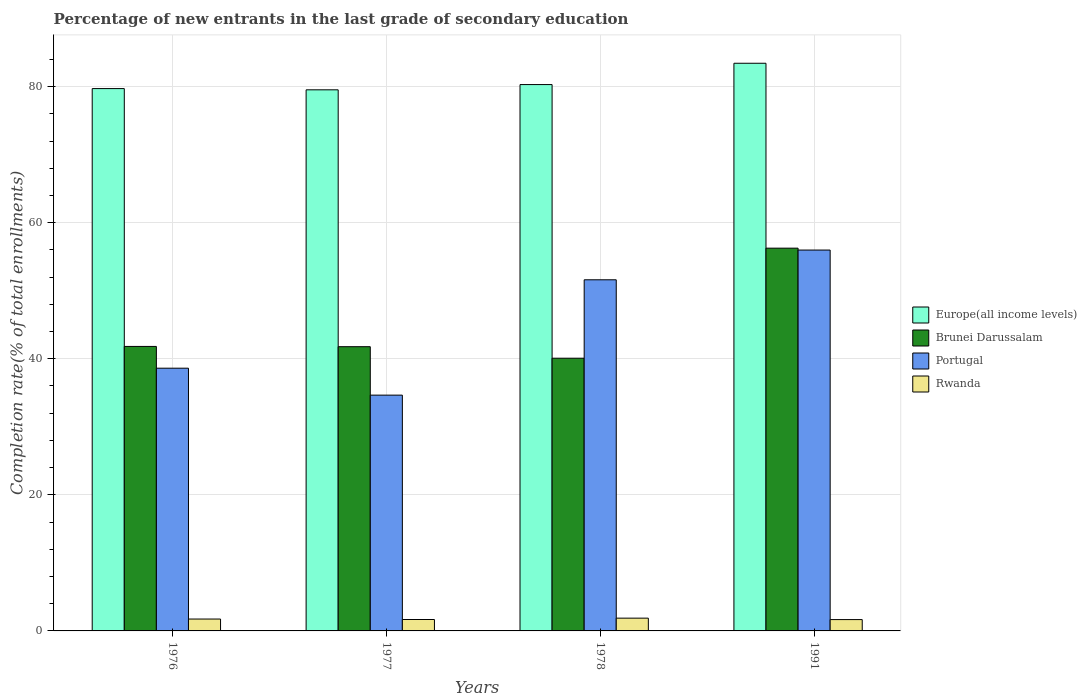How many groups of bars are there?
Make the answer very short. 4. How many bars are there on the 4th tick from the left?
Your answer should be compact. 4. How many bars are there on the 4th tick from the right?
Provide a succinct answer. 4. What is the label of the 4th group of bars from the left?
Ensure brevity in your answer.  1991. What is the percentage of new entrants in Brunei Darussalam in 1978?
Provide a short and direct response. 40.08. Across all years, what is the maximum percentage of new entrants in Europe(all income levels)?
Ensure brevity in your answer.  83.43. Across all years, what is the minimum percentage of new entrants in Brunei Darussalam?
Provide a short and direct response. 40.08. In which year was the percentage of new entrants in Portugal maximum?
Offer a very short reply. 1991. What is the total percentage of new entrants in Brunei Darussalam in the graph?
Your answer should be very brief. 179.92. What is the difference between the percentage of new entrants in Europe(all income levels) in 1977 and that in 1991?
Make the answer very short. -3.9. What is the difference between the percentage of new entrants in Rwanda in 1976 and the percentage of new entrants in Portugal in 1991?
Your response must be concise. -54.23. What is the average percentage of new entrants in Portugal per year?
Give a very brief answer. 45.21. In the year 1991, what is the difference between the percentage of new entrants in Portugal and percentage of new entrants in Brunei Darussalam?
Provide a short and direct response. -0.28. What is the ratio of the percentage of new entrants in Europe(all income levels) in 1976 to that in 1978?
Ensure brevity in your answer.  0.99. Is the difference between the percentage of new entrants in Portugal in 1976 and 1978 greater than the difference between the percentage of new entrants in Brunei Darussalam in 1976 and 1978?
Ensure brevity in your answer.  No. What is the difference between the highest and the second highest percentage of new entrants in Portugal?
Give a very brief answer. 4.37. What is the difference between the highest and the lowest percentage of new entrants in Brunei Darussalam?
Make the answer very short. 16.17. What does the 2nd bar from the right in 1977 represents?
Give a very brief answer. Portugal. Is it the case that in every year, the sum of the percentage of new entrants in Brunei Darussalam and percentage of new entrants in Europe(all income levels) is greater than the percentage of new entrants in Rwanda?
Provide a succinct answer. Yes. How many years are there in the graph?
Provide a short and direct response. 4. Are the values on the major ticks of Y-axis written in scientific E-notation?
Provide a succinct answer. No. Does the graph contain any zero values?
Offer a terse response. No. Does the graph contain grids?
Make the answer very short. Yes. How are the legend labels stacked?
Your response must be concise. Vertical. What is the title of the graph?
Offer a very short reply. Percentage of new entrants in the last grade of secondary education. What is the label or title of the X-axis?
Your answer should be very brief. Years. What is the label or title of the Y-axis?
Keep it short and to the point. Completion rate(% of total enrollments). What is the Completion rate(% of total enrollments) of Europe(all income levels) in 1976?
Provide a short and direct response. 79.71. What is the Completion rate(% of total enrollments) of Brunei Darussalam in 1976?
Provide a succinct answer. 41.81. What is the Completion rate(% of total enrollments) of Portugal in 1976?
Make the answer very short. 38.61. What is the Completion rate(% of total enrollments) of Rwanda in 1976?
Offer a very short reply. 1.75. What is the Completion rate(% of total enrollments) in Europe(all income levels) in 1977?
Ensure brevity in your answer.  79.53. What is the Completion rate(% of total enrollments) in Brunei Darussalam in 1977?
Offer a terse response. 41.77. What is the Completion rate(% of total enrollments) of Portugal in 1977?
Provide a short and direct response. 34.66. What is the Completion rate(% of total enrollments) of Rwanda in 1977?
Provide a short and direct response. 1.68. What is the Completion rate(% of total enrollments) in Europe(all income levels) in 1978?
Provide a succinct answer. 80.3. What is the Completion rate(% of total enrollments) in Brunei Darussalam in 1978?
Give a very brief answer. 40.08. What is the Completion rate(% of total enrollments) in Portugal in 1978?
Your response must be concise. 51.61. What is the Completion rate(% of total enrollments) of Rwanda in 1978?
Provide a succinct answer. 1.88. What is the Completion rate(% of total enrollments) in Europe(all income levels) in 1991?
Offer a very short reply. 83.43. What is the Completion rate(% of total enrollments) in Brunei Darussalam in 1991?
Keep it short and to the point. 56.26. What is the Completion rate(% of total enrollments) in Portugal in 1991?
Keep it short and to the point. 55.98. What is the Completion rate(% of total enrollments) of Rwanda in 1991?
Provide a short and direct response. 1.67. Across all years, what is the maximum Completion rate(% of total enrollments) in Europe(all income levels)?
Offer a terse response. 83.43. Across all years, what is the maximum Completion rate(% of total enrollments) of Brunei Darussalam?
Offer a very short reply. 56.26. Across all years, what is the maximum Completion rate(% of total enrollments) in Portugal?
Offer a terse response. 55.98. Across all years, what is the maximum Completion rate(% of total enrollments) of Rwanda?
Provide a succinct answer. 1.88. Across all years, what is the minimum Completion rate(% of total enrollments) of Europe(all income levels)?
Offer a very short reply. 79.53. Across all years, what is the minimum Completion rate(% of total enrollments) of Brunei Darussalam?
Ensure brevity in your answer.  40.08. Across all years, what is the minimum Completion rate(% of total enrollments) of Portugal?
Offer a terse response. 34.66. Across all years, what is the minimum Completion rate(% of total enrollments) in Rwanda?
Your answer should be compact. 1.67. What is the total Completion rate(% of total enrollments) of Europe(all income levels) in the graph?
Give a very brief answer. 322.97. What is the total Completion rate(% of total enrollments) in Brunei Darussalam in the graph?
Your answer should be compact. 179.92. What is the total Completion rate(% of total enrollments) in Portugal in the graph?
Ensure brevity in your answer.  180.86. What is the total Completion rate(% of total enrollments) of Rwanda in the graph?
Provide a succinct answer. 6.97. What is the difference between the Completion rate(% of total enrollments) of Europe(all income levels) in 1976 and that in 1977?
Your response must be concise. 0.18. What is the difference between the Completion rate(% of total enrollments) in Brunei Darussalam in 1976 and that in 1977?
Make the answer very short. 0.04. What is the difference between the Completion rate(% of total enrollments) in Portugal in 1976 and that in 1977?
Your answer should be compact. 3.96. What is the difference between the Completion rate(% of total enrollments) in Rwanda in 1976 and that in 1977?
Keep it short and to the point. 0.07. What is the difference between the Completion rate(% of total enrollments) of Europe(all income levels) in 1976 and that in 1978?
Your answer should be very brief. -0.59. What is the difference between the Completion rate(% of total enrollments) of Brunei Darussalam in 1976 and that in 1978?
Your answer should be compact. 1.73. What is the difference between the Completion rate(% of total enrollments) in Portugal in 1976 and that in 1978?
Your response must be concise. -12.99. What is the difference between the Completion rate(% of total enrollments) of Rwanda in 1976 and that in 1978?
Keep it short and to the point. -0.13. What is the difference between the Completion rate(% of total enrollments) in Europe(all income levels) in 1976 and that in 1991?
Offer a very short reply. -3.72. What is the difference between the Completion rate(% of total enrollments) in Brunei Darussalam in 1976 and that in 1991?
Give a very brief answer. -14.44. What is the difference between the Completion rate(% of total enrollments) of Portugal in 1976 and that in 1991?
Keep it short and to the point. -17.36. What is the difference between the Completion rate(% of total enrollments) of Rwanda in 1976 and that in 1991?
Keep it short and to the point. 0.08. What is the difference between the Completion rate(% of total enrollments) in Europe(all income levels) in 1977 and that in 1978?
Your answer should be very brief. -0.77. What is the difference between the Completion rate(% of total enrollments) of Brunei Darussalam in 1977 and that in 1978?
Provide a short and direct response. 1.69. What is the difference between the Completion rate(% of total enrollments) in Portugal in 1977 and that in 1978?
Provide a short and direct response. -16.95. What is the difference between the Completion rate(% of total enrollments) in Rwanda in 1977 and that in 1978?
Keep it short and to the point. -0.2. What is the difference between the Completion rate(% of total enrollments) in Europe(all income levels) in 1977 and that in 1991?
Make the answer very short. -3.9. What is the difference between the Completion rate(% of total enrollments) in Brunei Darussalam in 1977 and that in 1991?
Give a very brief answer. -14.48. What is the difference between the Completion rate(% of total enrollments) in Portugal in 1977 and that in 1991?
Offer a terse response. -21.32. What is the difference between the Completion rate(% of total enrollments) in Rwanda in 1977 and that in 1991?
Offer a very short reply. 0.01. What is the difference between the Completion rate(% of total enrollments) in Europe(all income levels) in 1978 and that in 1991?
Make the answer very short. -3.13. What is the difference between the Completion rate(% of total enrollments) of Brunei Darussalam in 1978 and that in 1991?
Offer a very short reply. -16.17. What is the difference between the Completion rate(% of total enrollments) of Portugal in 1978 and that in 1991?
Offer a terse response. -4.37. What is the difference between the Completion rate(% of total enrollments) of Rwanda in 1978 and that in 1991?
Your answer should be very brief. 0.21. What is the difference between the Completion rate(% of total enrollments) in Europe(all income levels) in 1976 and the Completion rate(% of total enrollments) in Brunei Darussalam in 1977?
Provide a succinct answer. 37.93. What is the difference between the Completion rate(% of total enrollments) of Europe(all income levels) in 1976 and the Completion rate(% of total enrollments) of Portugal in 1977?
Your answer should be compact. 45.05. What is the difference between the Completion rate(% of total enrollments) of Europe(all income levels) in 1976 and the Completion rate(% of total enrollments) of Rwanda in 1977?
Offer a very short reply. 78.03. What is the difference between the Completion rate(% of total enrollments) of Brunei Darussalam in 1976 and the Completion rate(% of total enrollments) of Portugal in 1977?
Your response must be concise. 7.16. What is the difference between the Completion rate(% of total enrollments) of Brunei Darussalam in 1976 and the Completion rate(% of total enrollments) of Rwanda in 1977?
Your answer should be very brief. 40.13. What is the difference between the Completion rate(% of total enrollments) of Portugal in 1976 and the Completion rate(% of total enrollments) of Rwanda in 1977?
Provide a succinct answer. 36.94. What is the difference between the Completion rate(% of total enrollments) in Europe(all income levels) in 1976 and the Completion rate(% of total enrollments) in Brunei Darussalam in 1978?
Provide a short and direct response. 39.63. What is the difference between the Completion rate(% of total enrollments) in Europe(all income levels) in 1976 and the Completion rate(% of total enrollments) in Portugal in 1978?
Provide a succinct answer. 28.1. What is the difference between the Completion rate(% of total enrollments) in Europe(all income levels) in 1976 and the Completion rate(% of total enrollments) in Rwanda in 1978?
Your response must be concise. 77.83. What is the difference between the Completion rate(% of total enrollments) of Brunei Darussalam in 1976 and the Completion rate(% of total enrollments) of Portugal in 1978?
Provide a short and direct response. -9.79. What is the difference between the Completion rate(% of total enrollments) of Brunei Darussalam in 1976 and the Completion rate(% of total enrollments) of Rwanda in 1978?
Your answer should be compact. 39.94. What is the difference between the Completion rate(% of total enrollments) in Portugal in 1976 and the Completion rate(% of total enrollments) in Rwanda in 1978?
Ensure brevity in your answer.  36.74. What is the difference between the Completion rate(% of total enrollments) of Europe(all income levels) in 1976 and the Completion rate(% of total enrollments) of Brunei Darussalam in 1991?
Your response must be concise. 23.45. What is the difference between the Completion rate(% of total enrollments) of Europe(all income levels) in 1976 and the Completion rate(% of total enrollments) of Portugal in 1991?
Provide a succinct answer. 23.73. What is the difference between the Completion rate(% of total enrollments) of Europe(all income levels) in 1976 and the Completion rate(% of total enrollments) of Rwanda in 1991?
Offer a very short reply. 78.04. What is the difference between the Completion rate(% of total enrollments) of Brunei Darussalam in 1976 and the Completion rate(% of total enrollments) of Portugal in 1991?
Offer a very short reply. -14.16. What is the difference between the Completion rate(% of total enrollments) in Brunei Darussalam in 1976 and the Completion rate(% of total enrollments) in Rwanda in 1991?
Provide a short and direct response. 40.15. What is the difference between the Completion rate(% of total enrollments) in Portugal in 1976 and the Completion rate(% of total enrollments) in Rwanda in 1991?
Your answer should be compact. 36.95. What is the difference between the Completion rate(% of total enrollments) of Europe(all income levels) in 1977 and the Completion rate(% of total enrollments) of Brunei Darussalam in 1978?
Offer a very short reply. 39.45. What is the difference between the Completion rate(% of total enrollments) of Europe(all income levels) in 1977 and the Completion rate(% of total enrollments) of Portugal in 1978?
Make the answer very short. 27.92. What is the difference between the Completion rate(% of total enrollments) in Europe(all income levels) in 1977 and the Completion rate(% of total enrollments) in Rwanda in 1978?
Your response must be concise. 77.65. What is the difference between the Completion rate(% of total enrollments) of Brunei Darussalam in 1977 and the Completion rate(% of total enrollments) of Portugal in 1978?
Ensure brevity in your answer.  -9.83. What is the difference between the Completion rate(% of total enrollments) in Brunei Darussalam in 1977 and the Completion rate(% of total enrollments) in Rwanda in 1978?
Your response must be concise. 39.9. What is the difference between the Completion rate(% of total enrollments) in Portugal in 1977 and the Completion rate(% of total enrollments) in Rwanda in 1978?
Your response must be concise. 32.78. What is the difference between the Completion rate(% of total enrollments) of Europe(all income levels) in 1977 and the Completion rate(% of total enrollments) of Brunei Darussalam in 1991?
Offer a terse response. 23.27. What is the difference between the Completion rate(% of total enrollments) in Europe(all income levels) in 1977 and the Completion rate(% of total enrollments) in Portugal in 1991?
Your response must be concise. 23.55. What is the difference between the Completion rate(% of total enrollments) of Europe(all income levels) in 1977 and the Completion rate(% of total enrollments) of Rwanda in 1991?
Keep it short and to the point. 77.86. What is the difference between the Completion rate(% of total enrollments) of Brunei Darussalam in 1977 and the Completion rate(% of total enrollments) of Portugal in 1991?
Your response must be concise. -14.2. What is the difference between the Completion rate(% of total enrollments) of Brunei Darussalam in 1977 and the Completion rate(% of total enrollments) of Rwanda in 1991?
Give a very brief answer. 40.11. What is the difference between the Completion rate(% of total enrollments) in Portugal in 1977 and the Completion rate(% of total enrollments) in Rwanda in 1991?
Provide a succinct answer. 32.99. What is the difference between the Completion rate(% of total enrollments) in Europe(all income levels) in 1978 and the Completion rate(% of total enrollments) in Brunei Darussalam in 1991?
Ensure brevity in your answer.  24.04. What is the difference between the Completion rate(% of total enrollments) in Europe(all income levels) in 1978 and the Completion rate(% of total enrollments) in Portugal in 1991?
Provide a short and direct response. 24.32. What is the difference between the Completion rate(% of total enrollments) of Europe(all income levels) in 1978 and the Completion rate(% of total enrollments) of Rwanda in 1991?
Provide a succinct answer. 78.63. What is the difference between the Completion rate(% of total enrollments) in Brunei Darussalam in 1978 and the Completion rate(% of total enrollments) in Portugal in 1991?
Keep it short and to the point. -15.9. What is the difference between the Completion rate(% of total enrollments) of Brunei Darussalam in 1978 and the Completion rate(% of total enrollments) of Rwanda in 1991?
Your answer should be compact. 38.41. What is the difference between the Completion rate(% of total enrollments) in Portugal in 1978 and the Completion rate(% of total enrollments) in Rwanda in 1991?
Provide a succinct answer. 49.94. What is the average Completion rate(% of total enrollments) of Europe(all income levels) per year?
Make the answer very short. 80.74. What is the average Completion rate(% of total enrollments) of Brunei Darussalam per year?
Make the answer very short. 44.98. What is the average Completion rate(% of total enrollments) of Portugal per year?
Make the answer very short. 45.21. What is the average Completion rate(% of total enrollments) in Rwanda per year?
Your answer should be compact. 1.74. In the year 1976, what is the difference between the Completion rate(% of total enrollments) in Europe(all income levels) and Completion rate(% of total enrollments) in Brunei Darussalam?
Offer a very short reply. 37.9. In the year 1976, what is the difference between the Completion rate(% of total enrollments) in Europe(all income levels) and Completion rate(% of total enrollments) in Portugal?
Make the answer very short. 41.09. In the year 1976, what is the difference between the Completion rate(% of total enrollments) in Europe(all income levels) and Completion rate(% of total enrollments) in Rwanda?
Your response must be concise. 77.96. In the year 1976, what is the difference between the Completion rate(% of total enrollments) of Brunei Darussalam and Completion rate(% of total enrollments) of Portugal?
Provide a short and direct response. 3.2. In the year 1976, what is the difference between the Completion rate(% of total enrollments) of Brunei Darussalam and Completion rate(% of total enrollments) of Rwanda?
Your response must be concise. 40.07. In the year 1976, what is the difference between the Completion rate(% of total enrollments) in Portugal and Completion rate(% of total enrollments) in Rwanda?
Your answer should be compact. 36.87. In the year 1977, what is the difference between the Completion rate(% of total enrollments) of Europe(all income levels) and Completion rate(% of total enrollments) of Brunei Darussalam?
Your answer should be very brief. 37.75. In the year 1977, what is the difference between the Completion rate(% of total enrollments) of Europe(all income levels) and Completion rate(% of total enrollments) of Portugal?
Your answer should be very brief. 44.87. In the year 1977, what is the difference between the Completion rate(% of total enrollments) of Europe(all income levels) and Completion rate(% of total enrollments) of Rwanda?
Your answer should be very brief. 77.85. In the year 1977, what is the difference between the Completion rate(% of total enrollments) of Brunei Darussalam and Completion rate(% of total enrollments) of Portugal?
Your response must be concise. 7.12. In the year 1977, what is the difference between the Completion rate(% of total enrollments) of Brunei Darussalam and Completion rate(% of total enrollments) of Rwanda?
Keep it short and to the point. 40.1. In the year 1977, what is the difference between the Completion rate(% of total enrollments) of Portugal and Completion rate(% of total enrollments) of Rwanda?
Provide a succinct answer. 32.98. In the year 1978, what is the difference between the Completion rate(% of total enrollments) of Europe(all income levels) and Completion rate(% of total enrollments) of Brunei Darussalam?
Make the answer very short. 40.22. In the year 1978, what is the difference between the Completion rate(% of total enrollments) of Europe(all income levels) and Completion rate(% of total enrollments) of Portugal?
Keep it short and to the point. 28.69. In the year 1978, what is the difference between the Completion rate(% of total enrollments) in Europe(all income levels) and Completion rate(% of total enrollments) in Rwanda?
Your answer should be very brief. 78.42. In the year 1978, what is the difference between the Completion rate(% of total enrollments) in Brunei Darussalam and Completion rate(% of total enrollments) in Portugal?
Provide a succinct answer. -11.53. In the year 1978, what is the difference between the Completion rate(% of total enrollments) of Brunei Darussalam and Completion rate(% of total enrollments) of Rwanda?
Provide a short and direct response. 38.2. In the year 1978, what is the difference between the Completion rate(% of total enrollments) of Portugal and Completion rate(% of total enrollments) of Rwanda?
Offer a terse response. 49.73. In the year 1991, what is the difference between the Completion rate(% of total enrollments) of Europe(all income levels) and Completion rate(% of total enrollments) of Brunei Darussalam?
Your answer should be compact. 27.18. In the year 1991, what is the difference between the Completion rate(% of total enrollments) of Europe(all income levels) and Completion rate(% of total enrollments) of Portugal?
Your response must be concise. 27.45. In the year 1991, what is the difference between the Completion rate(% of total enrollments) of Europe(all income levels) and Completion rate(% of total enrollments) of Rwanda?
Give a very brief answer. 81.77. In the year 1991, what is the difference between the Completion rate(% of total enrollments) in Brunei Darussalam and Completion rate(% of total enrollments) in Portugal?
Your response must be concise. 0.28. In the year 1991, what is the difference between the Completion rate(% of total enrollments) of Brunei Darussalam and Completion rate(% of total enrollments) of Rwanda?
Your answer should be compact. 54.59. In the year 1991, what is the difference between the Completion rate(% of total enrollments) in Portugal and Completion rate(% of total enrollments) in Rwanda?
Your response must be concise. 54.31. What is the ratio of the Completion rate(% of total enrollments) in Europe(all income levels) in 1976 to that in 1977?
Offer a terse response. 1. What is the ratio of the Completion rate(% of total enrollments) of Portugal in 1976 to that in 1977?
Offer a very short reply. 1.11. What is the ratio of the Completion rate(% of total enrollments) in Rwanda in 1976 to that in 1977?
Give a very brief answer. 1.04. What is the ratio of the Completion rate(% of total enrollments) in Europe(all income levels) in 1976 to that in 1978?
Your response must be concise. 0.99. What is the ratio of the Completion rate(% of total enrollments) of Brunei Darussalam in 1976 to that in 1978?
Ensure brevity in your answer.  1.04. What is the ratio of the Completion rate(% of total enrollments) of Portugal in 1976 to that in 1978?
Make the answer very short. 0.75. What is the ratio of the Completion rate(% of total enrollments) in Rwanda in 1976 to that in 1978?
Provide a short and direct response. 0.93. What is the ratio of the Completion rate(% of total enrollments) in Europe(all income levels) in 1976 to that in 1991?
Offer a very short reply. 0.96. What is the ratio of the Completion rate(% of total enrollments) in Brunei Darussalam in 1976 to that in 1991?
Your answer should be very brief. 0.74. What is the ratio of the Completion rate(% of total enrollments) of Portugal in 1976 to that in 1991?
Make the answer very short. 0.69. What is the ratio of the Completion rate(% of total enrollments) in Rwanda in 1976 to that in 1991?
Provide a succinct answer. 1.05. What is the ratio of the Completion rate(% of total enrollments) of Europe(all income levels) in 1977 to that in 1978?
Make the answer very short. 0.99. What is the ratio of the Completion rate(% of total enrollments) of Brunei Darussalam in 1977 to that in 1978?
Your response must be concise. 1.04. What is the ratio of the Completion rate(% of total enrollments) of Portugal in 1977 to that in 1978?
Your answer should be very brief. 0.67. What is the ratio of the Completion rate(% of total enrollments) of Rwanda in 1977 to that in 1978?
Make the answer very short. 0.89. What is the ratio of the Completion rate(% of total enrollments) of Europe(all income levels) in 1977 to that in 1991?
Provide a succinct answer. 0.95. What is the ratio of the Completion rate(% of total enrollments) of Brunei Darussalam in 1977 to that in 1991?
Your answer should be compact. 0.74. What is the ratio of the Completion rate(% of total enrollments) of Portugal in 1977 to that in 1991?
Your answer should be compact. 0.62. What is the ratio of the Completion rate(% of total enrollments) of Europe(all income levels) in 1978 to that in 1991?
Ensure brevity in your answer.  0.96. What is the ratio of the Completion rate(% of total enrollments) in Brunei Darussalam in 1978 to that in 1991?
Offer a terse response. 0.71. What is the ratio of the Completion rate(% of total enrollments) in Portugal in 1978 to that in 1991?
Ensure brevity in your answer.  0.92. What is the ratio of the Completion rate(% of total enrollments) of Rwanda in 1978 to that in 1991?
Provide a short and direct response. 1.13. What is the difference between the highest and the second highest Completion rate(% of total enrollments) of Europe(all income levels)?
Provide a succinct answer. 3.13. What is the difference between the highest and the second highest Completion rate(% of total enrollments) in Brunei Darussalam?
Your answer should be compact. 14.44. What is the difference between the highest and the second highest Completion rate(% of total enrollments) in Portugal?
Offer a very short reply. 4.37. What is the difference between the highest and the second highest Completion rate(% of total enrollments) of Rwanda?
Offer a terse response. 0.13. What is the difference between the highest and the lowest Completion rate(% of total enrollments) of Europe(all income levels)?
Your answer should be very brief. 3.9. What is the difference between the highest and the lowest Completion rate(% of total enrollments) in Brunei Darussalam?
Your answer should be compact. 16.17. What is the difference between the highest and the lowest Completion rate(% of total enrollments) of Portugal?
Your answer should be very brief. 21.32. What is the difference between the highest and the lowest Completion rate(% of total enrollments) of Rwanda?
Make the answer very short. 0.21. 